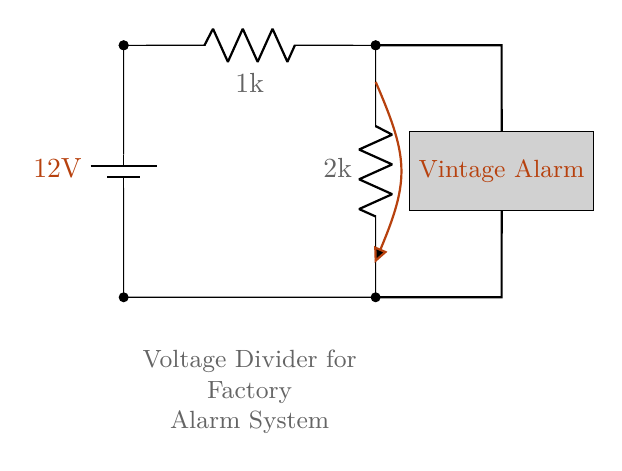What is the supply voltage for this circuit? The supply voltage is indicated on the battery symbol in the circuit diagram, which shows a value of 12 volts.
Answer: 12 volts What are the resistance values in the voltage divider? The circuit contains two resistors: one labeled as 1 kilohm and the other as 2 kilohms. These values are specified next to each resistor in the diagram.
Answer: 1 kilohm and 2 kilohms What is the output voltage from the voltage divider? The output voltage, labeled as Vout, is calculated using the voltage divider formula. Since R1 is 1 kilohm and R2 is 2 kilohms, Vout equals one-third of the supply voltage, which in this scenario is 4 volts.
Answer: 4 volts Which component represents the alarm system? The alarm system is represented by a rectangular block labeled "Vintage Alarm." It is visually distinct and provides a clear identification of the component within the circuit.
Answer: Vintage Alarm How does changing R2 to 3 kilohms affect Vout? Increasing R2 would increase the total resistance in the voltage divider, which would lower the output voltage. The new Vout can be calculated using: Vout = (R1 / (R1 + R2)) * Vs. Based on R2 changed to 3 kilohms, Vout would now be 4.5 volts.
Answer: Vout would decrease What is the purpose of a voltage divider in this circuit? The voltage divider is used to reduce the voltage from the supply voltage to a level suitable for powering the alarm system. By configuring the resistors, the output voltage is tailored for the alarm's requirements.
Answer: To reduce the voltage for the alarm 